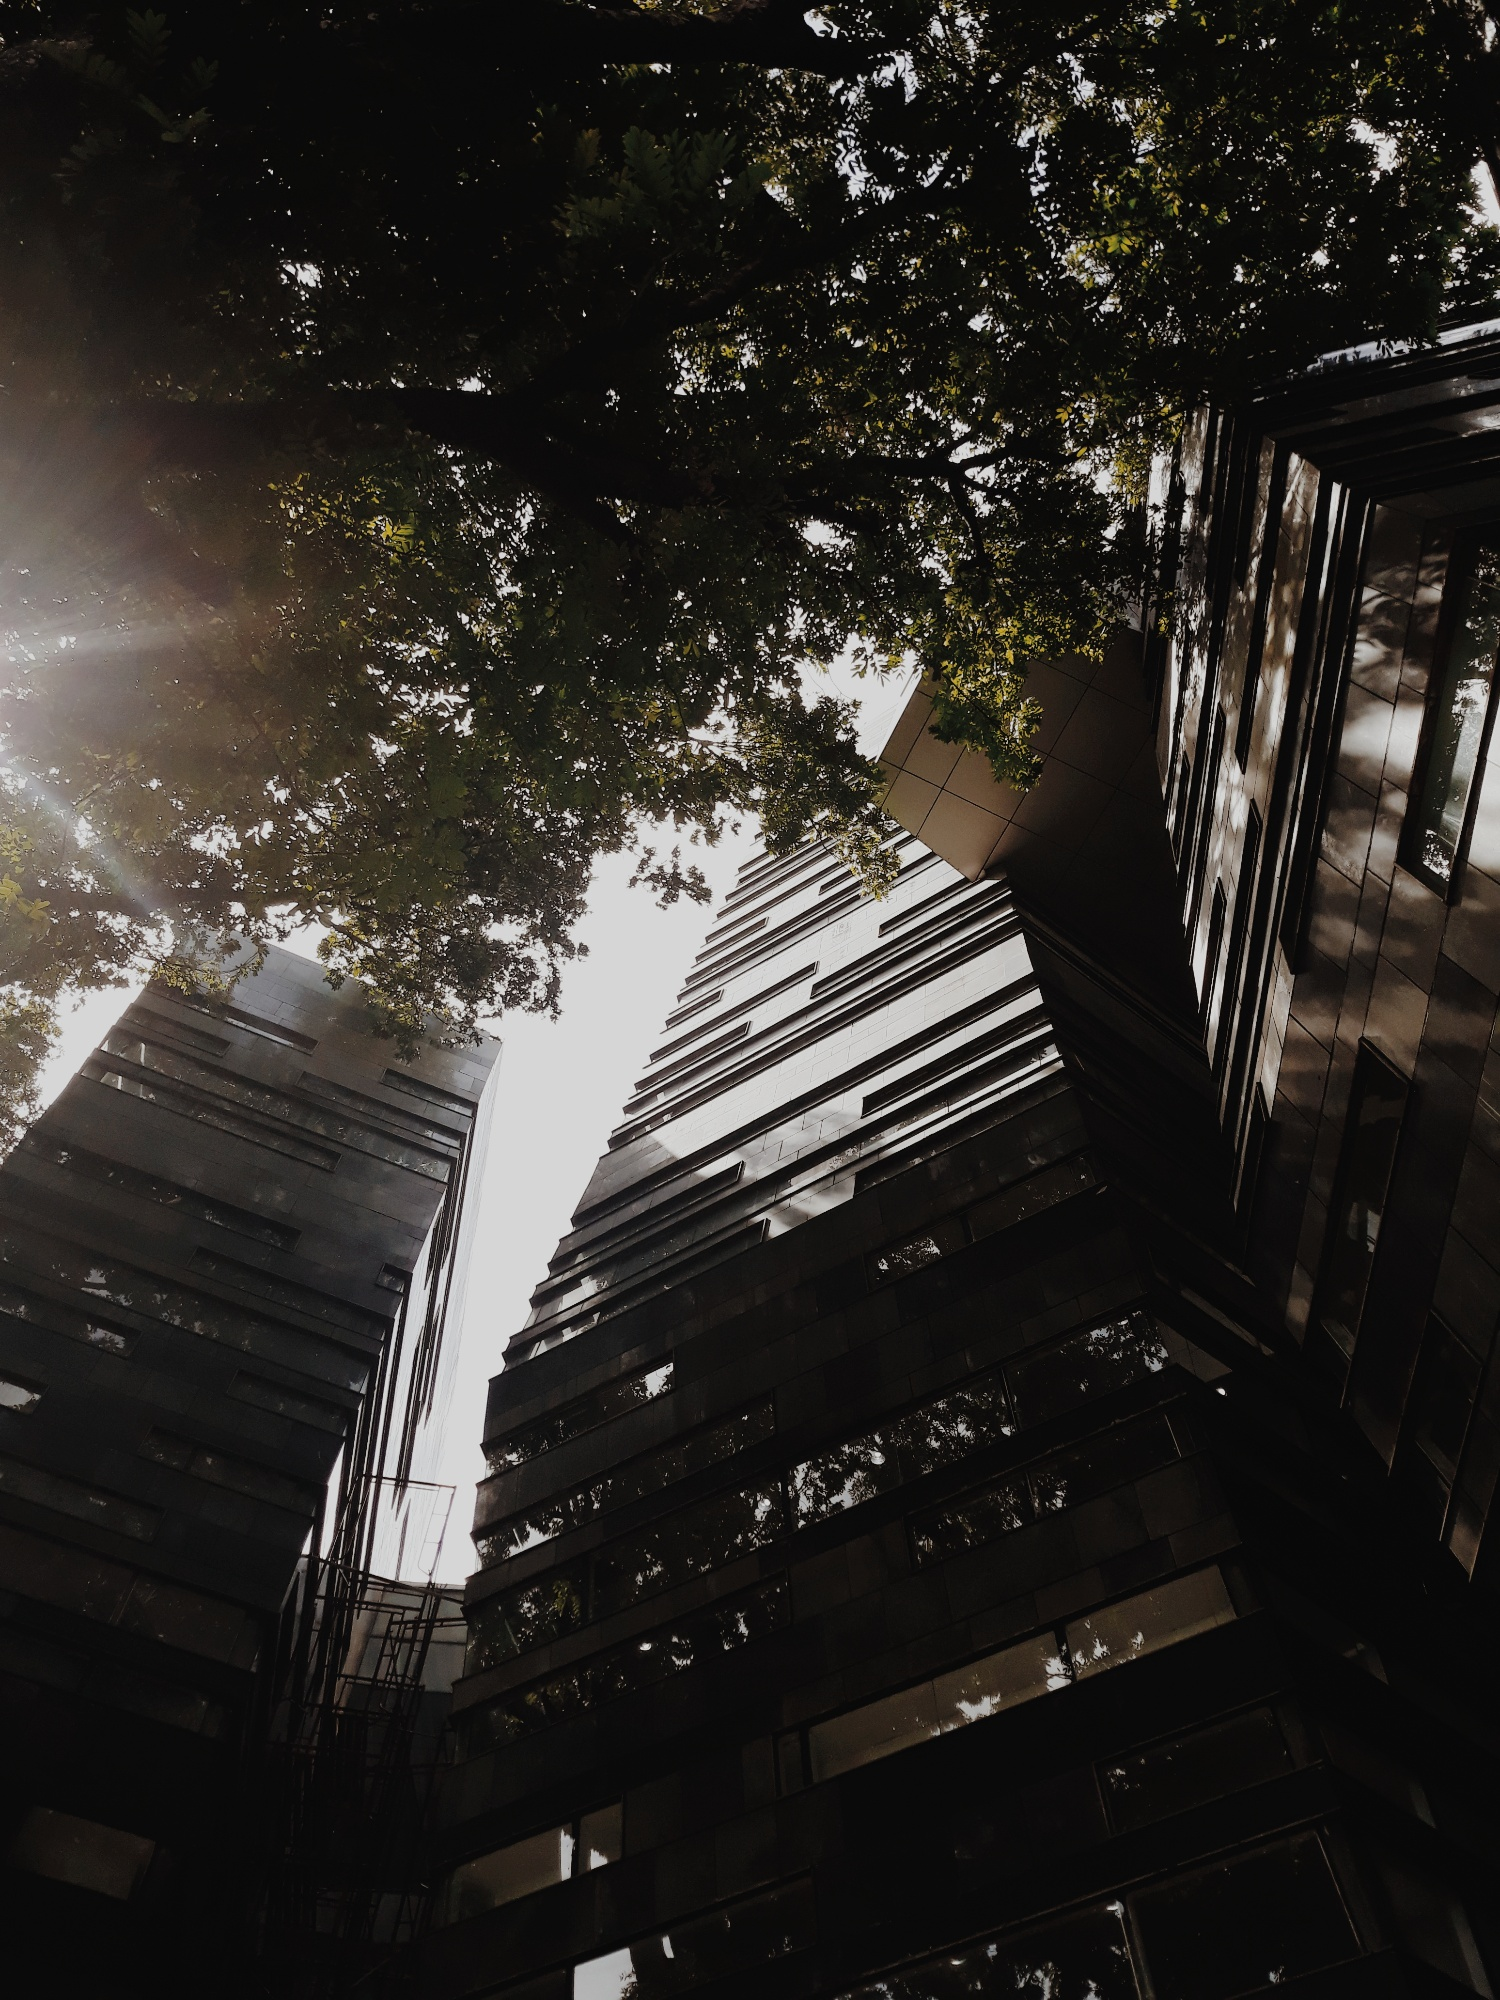What might be the functional benefits of the building’s zigzag facade design, as observed in the picture? The zigzag pattern of the facade likely serves several practical purposes beyond its aesthetic appeal. Structurally, such designs can help distribute the load more evenly across the building's frame, enhancing its stability. Aesthetically, the shifting angles capture and reflect light in varying ways throughout the day, creating a visually engaging play of light and shadows that can make the building more visually interesting and dynamic. Additionally, this design could potentially aid in energy efficiency, as it may help to minimize direct sunlight exposure and heat absorption during peak hours, thereby reducing cooling costs. 